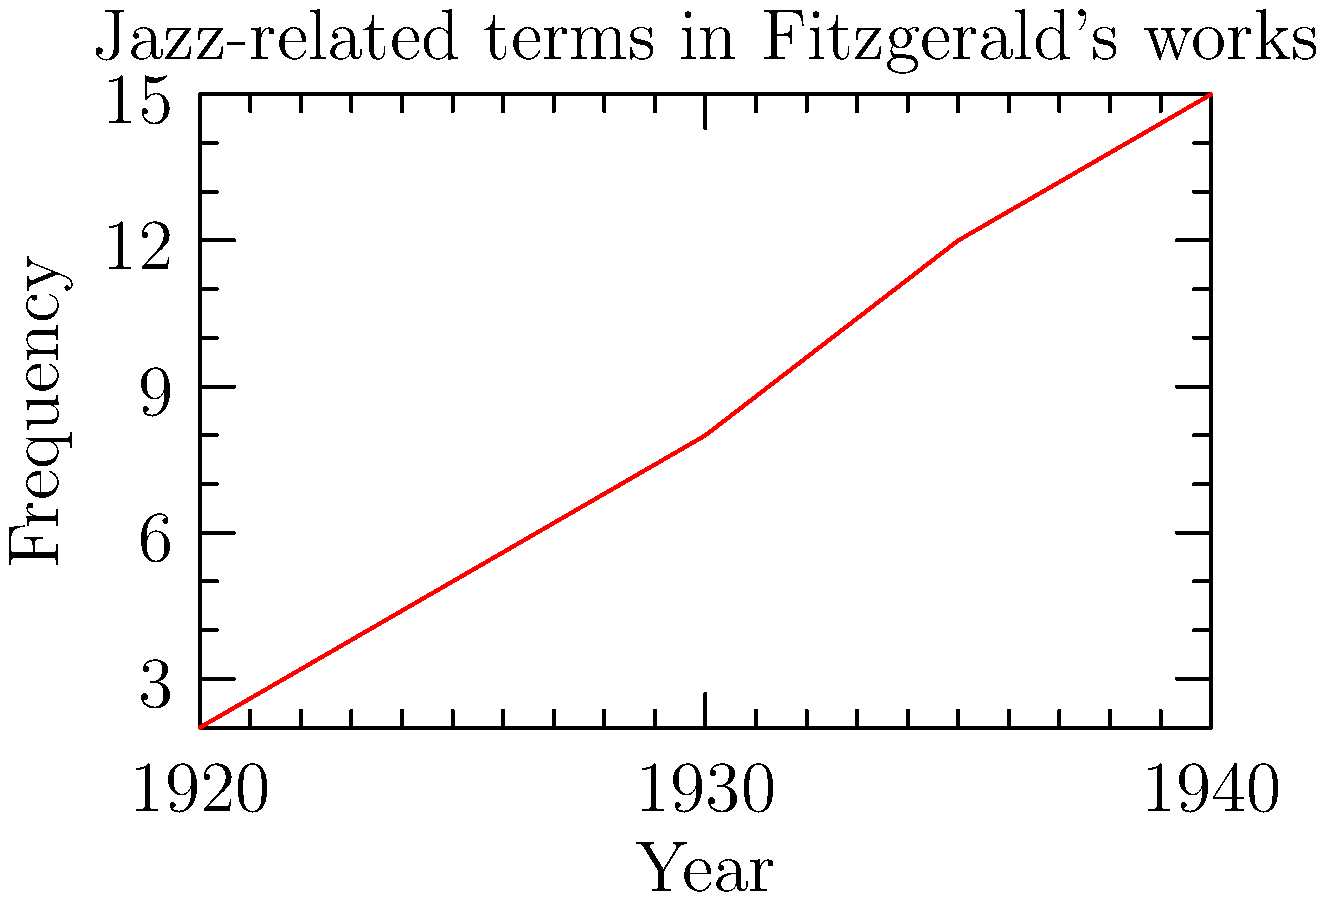Based on the line chart showing the frequency of jazz-related terms in F. Scott Fitzgerald's works over time, what literary trend does this graph suggest about Fitzgerald's writing style and thematic focus between 1920 and 1940? To answer this question, let's analyze the graph step-by-step:

1. The x-axis represents the years from 1920 to 1940, covering a significant period of Fitzgerald's writing career.
2. The y-axis shows the frequency of jazz-related terms in his works.
3. We can observe a clear upward trend in the line:
   - In 1920, the frequency is relatively low (around 2).
   - By 1925, there's a slight increase (to about 5).
   - The line continues to rise steadily through 1930 (around 8) and 1935 (about 12).
   - By 1940, the frequency reaches its highest point (approximately 15).

4. This consistent increase suggests that Fitzgerald increasingly incorporated jazz-related terms and themes into his writing over time.
5. The trend aligns with the historical context: the 1920s and 1930s saw the rise of the Jazz Age and its influence on American culture.
6. Fitzgerald is known for capturing the spirit of the Jazz Age in his works, particularly in novels like "The Great Gatsby" (1925).

Given this analysis, we can conclude that the graph suggests a growing integration of jazz culture and terminology into Fitzgerald's literary style and thematic focus. This trend reflects his increasing engagement with the cultural zeitgeist of the Jazz Age and its lasting impact on his writing throughout his career.
Answer: Increasing integration of jazz culture in Fitzgerald's writing 